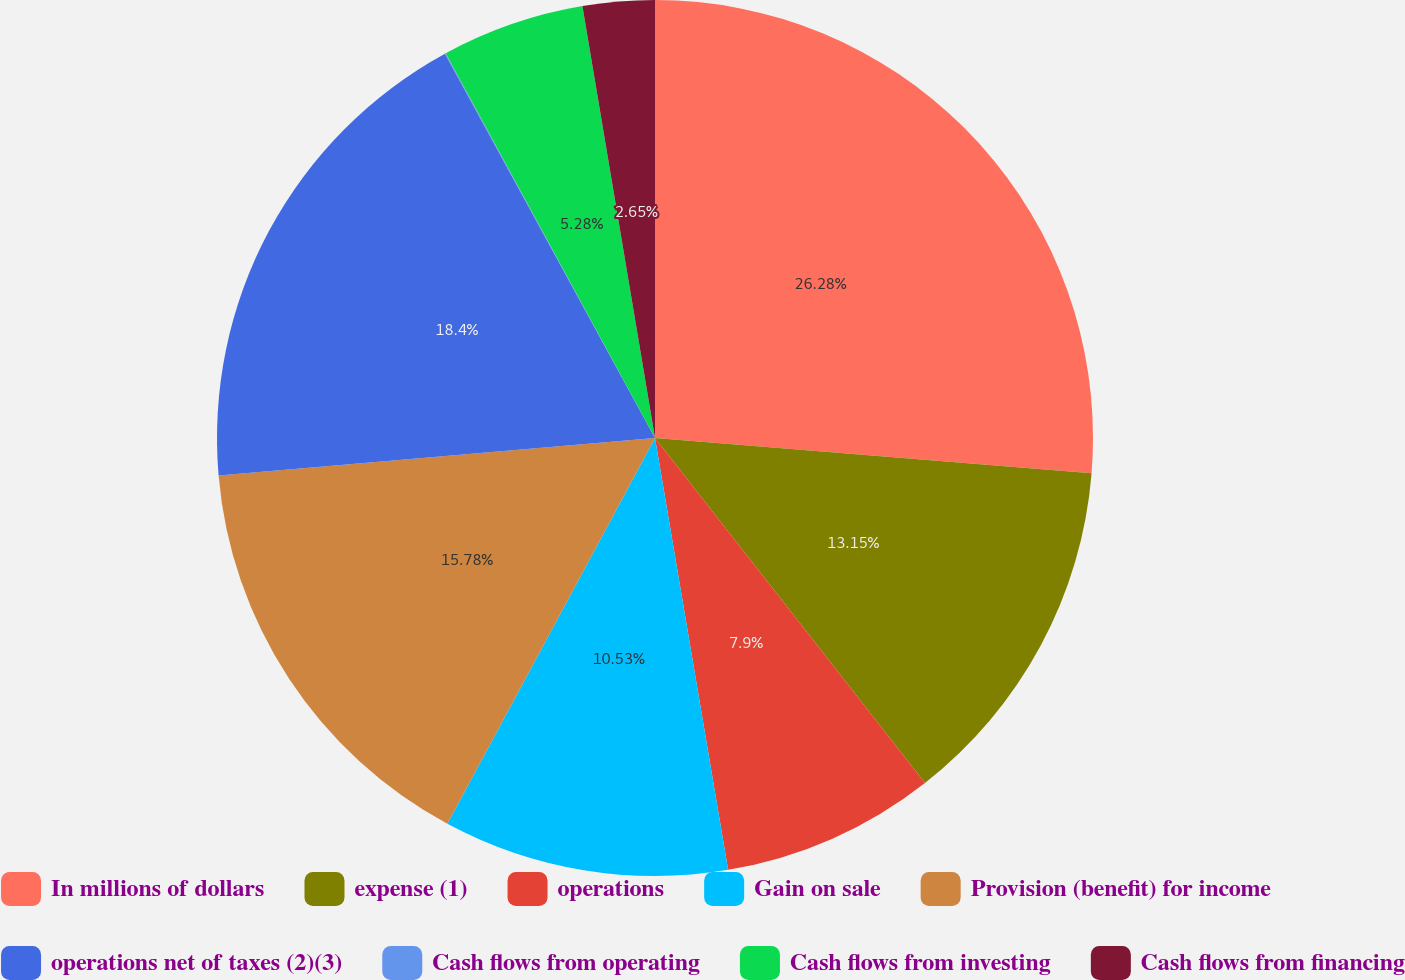Convert chart. <chart><loc_0><loc_0><loc_500><loc_500><pie_chart><fcel>In millions of dollars<fcel>expense (1)<fcel>operations<fcel>Gain on sale<fcel>Provision (benefit) for income<fcel>operations net of taxes (2)(3)<fcel>Cash flows from operating<fcel>Cash flows from investing<fcel>Cash flows from financing<nl><fcel>26.28%<fcel>13.15%<fcel>7.9%<fcel>10.53%<fcel>15.78%<fcel>18.4%<fcel>0.03%<fcel>5.28%<fcel>2.65%<nl></chart> 